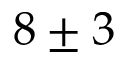<formula> <loc_0><loc_0><loc_500><loc_500>8 \pm 3</formula> 